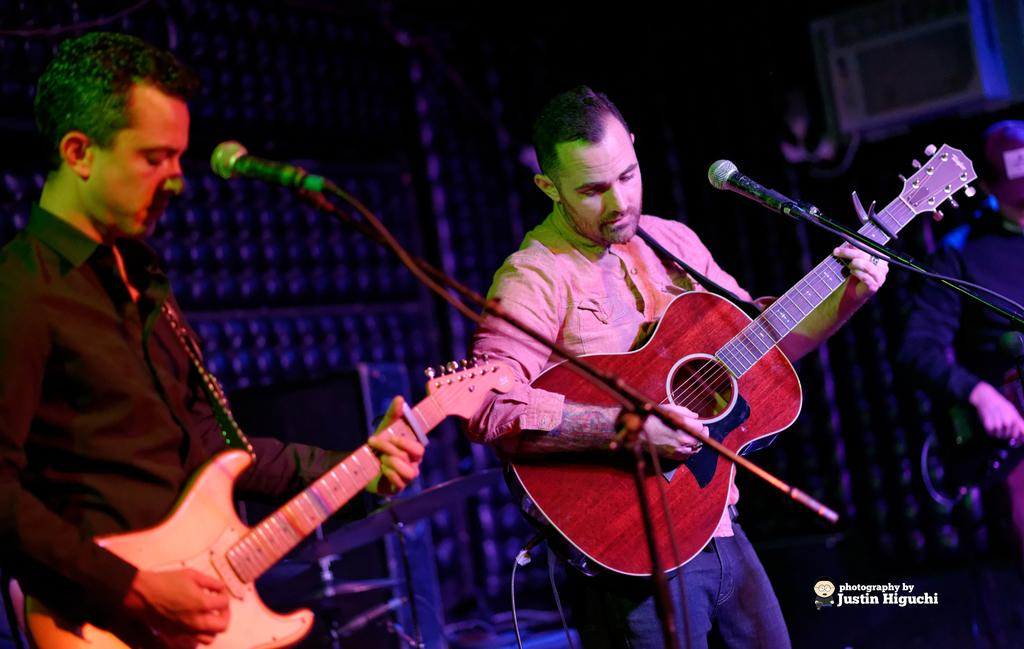How many people are in the image? There are two men in the image. What are the men holding in the image? The men are holding guitars. What can be seen behind the men? There is a microphone in front of the men, and another person is visible in the background of the image. What type of yak can be seen in the background of the image? There is no yak present in the image; it features two men holding guitars and standing in front of a microphone. What achievements has the person in the background accomplished? The image does not provide any information about the achievements of the person in the background. 